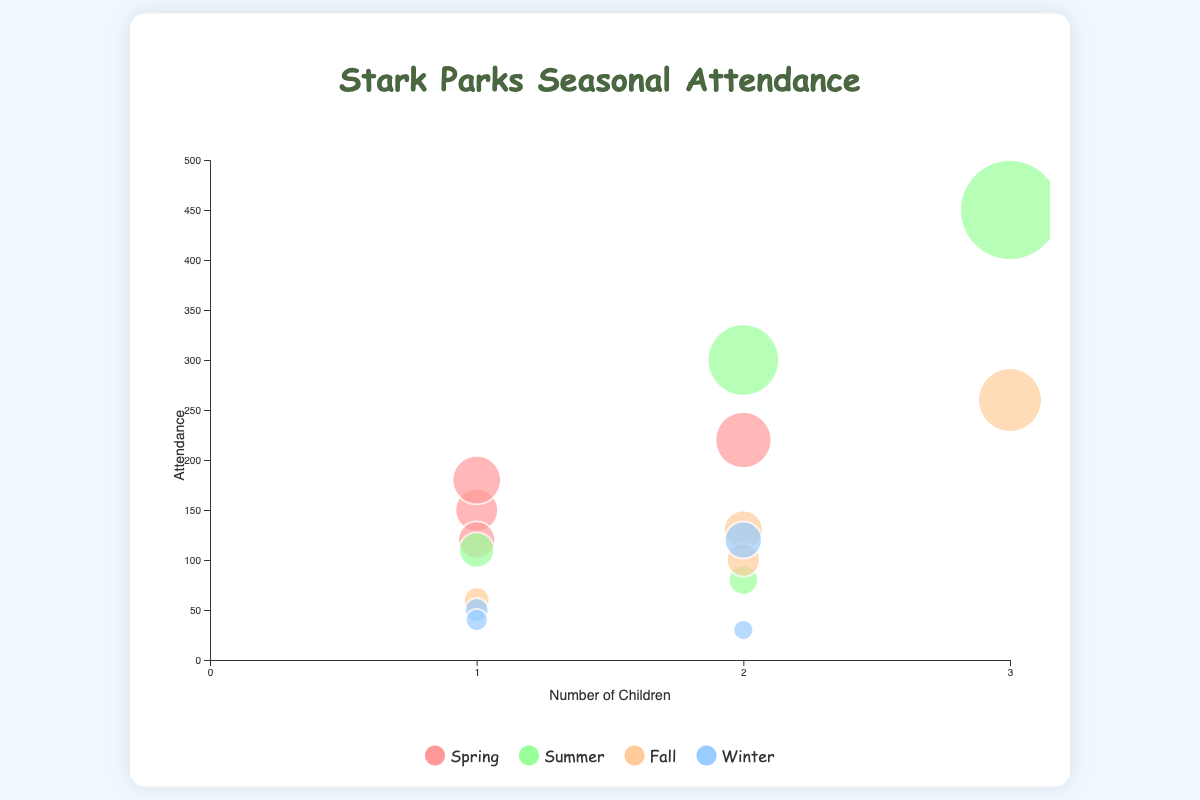What does the title of the figure say? The title of the figure is usually positioned at the top and helps identify the subject of the visualization.
Answer: Stark Parks Seasonal Attendance How many seasons are represented in the chart? To find the number of seasons, look at the legend of the chart which shows distinct colors for each season. There are four legend items, each with a different color.
Answer: Four Which season has the highest attendance on weekends with sunny weather? Look for the largest bubble in weekend and sunny conditions. The bubble for Summer on weekends in sunny weather is the largest at 450.
Answer: Summer During which season is attendance lowest on weekdays with rainy weather? Find the smallest bubble positioned in weekdays and rainy conditions. Winter has the lowest weekday rainy attendance with 30.
Answer: Winter Compare the attendance in Spring and Fall on weekends with sunny weather. Which one is higher? Identify the bubbles for Spring and Fall on weekends with sunny weather and compare their sizes. Fall's weekend sunny attendance (260) is higher than Spring's (220).
Answer: Fall Which weather condition generally shows the lowest attendance? Compare the size of bubbles across all weather conditions. Rainy and Snowy conditions have smaller bubbles compared to Sunny and Cloudy conditions.
Answer: Rainy/Snowy What is the average attendance on weekends in Winter, regardless of weather? Sum all weekend attendances in Winter (Sunny: 120, Snowy: 40) and divide by the number of weekends. (120 + 40) / 2 = 80
Answer: 80 Is attendance generally higher on weekends or weekdays in Summer, and by how much? Sum all Summer attendances for weekdays (380) and weekends (560) and compare. Weekends have higher attendance. 560 - 380 = 180
Answer: Weekends by 180 For families with three children, during which season and day type do they visit the park the most? Look for the bubble that represents families with three children and check each season and day type. Summer on weekends with Sunny weather has the highest (450).
Answer: Summer/Weekend 